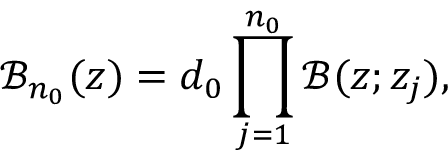<formula> <loc_0><loc_0><loc_500><loc_500>\mathcal { B } _ { n _ { 0 } } ( z ) = d _ { 0 } \prod _ { j = 1 } ^ { n _ { 0 } } \mathcal { B } ( z ; z _ { j } ) ,</formula> 